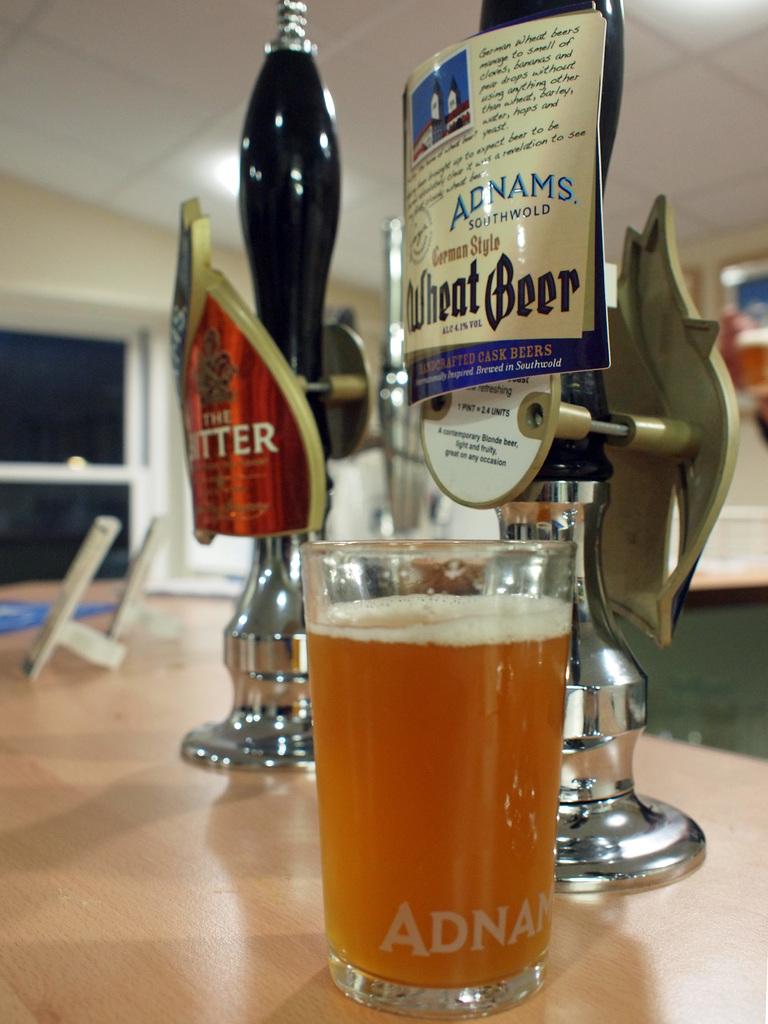What kind of beer is on tap?
Make the answer very short. Wheat beer. 